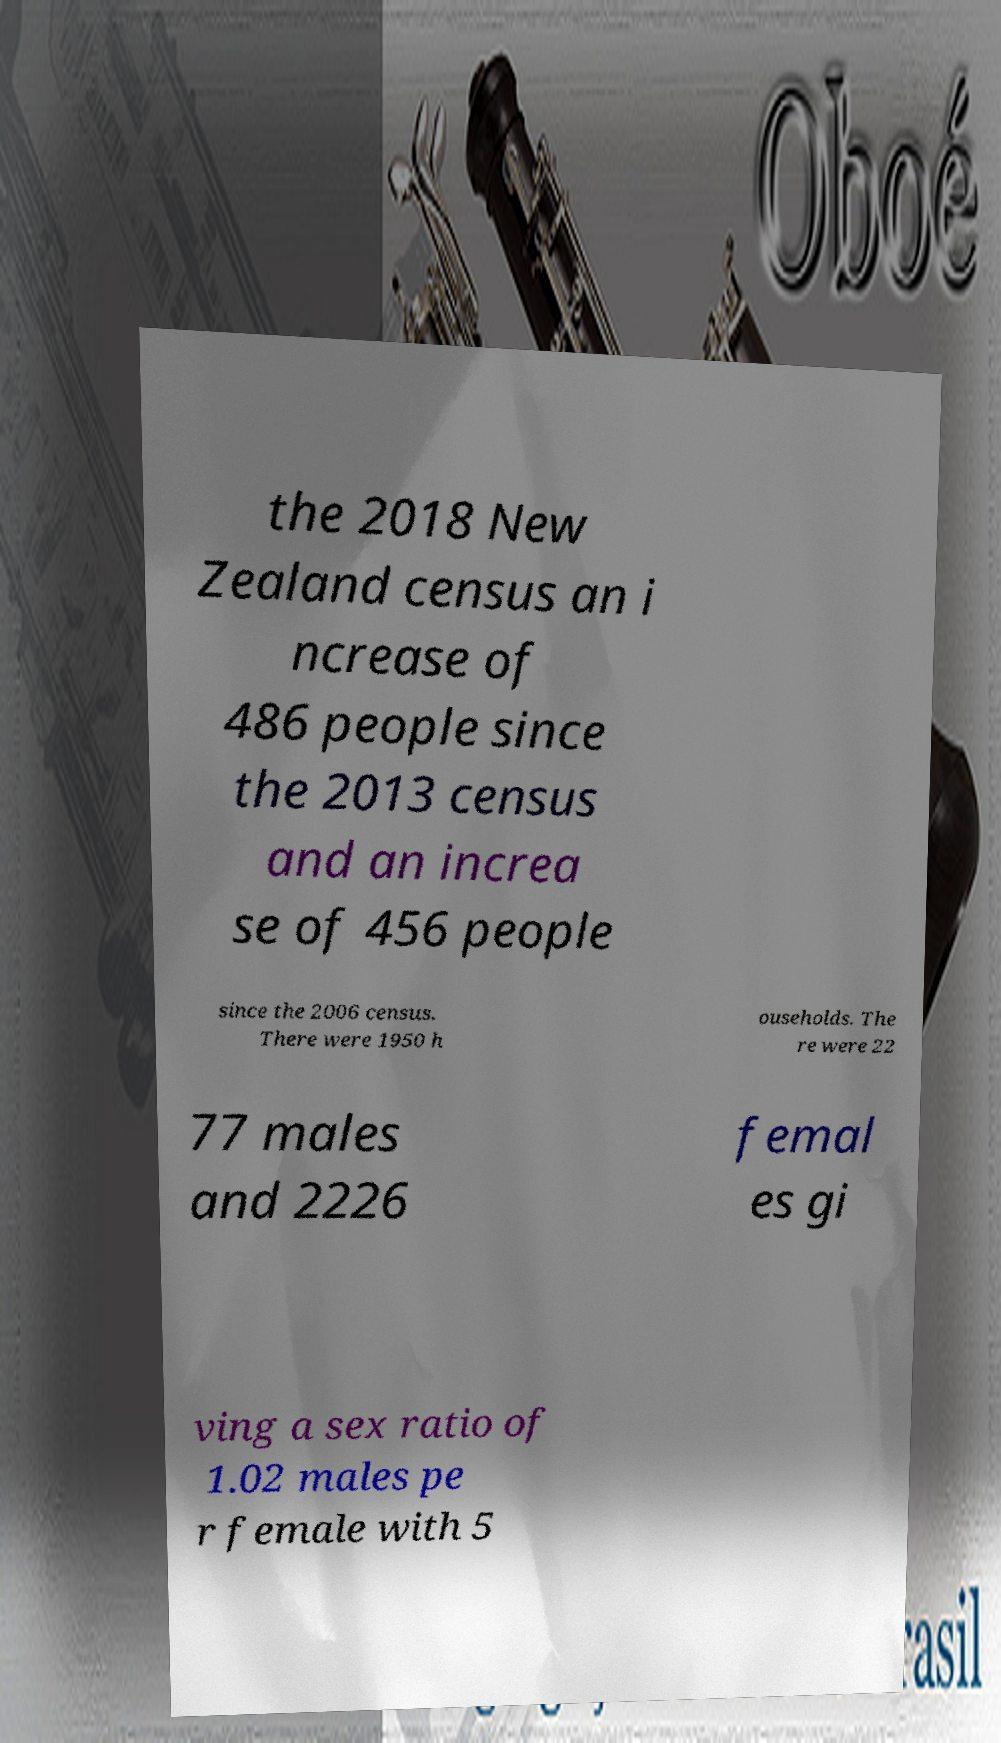Please identify and transcribe the text found in this image. the 2018 New Zealand census an i ncrease of 486 people since the 2013 census and an increa se of 456 people since the 2006 census. There were 1950 h ouseholds. The re were 22 77 males and 2226 femal es gi ving a sex ratio of 1.02 males pe r female with 5 